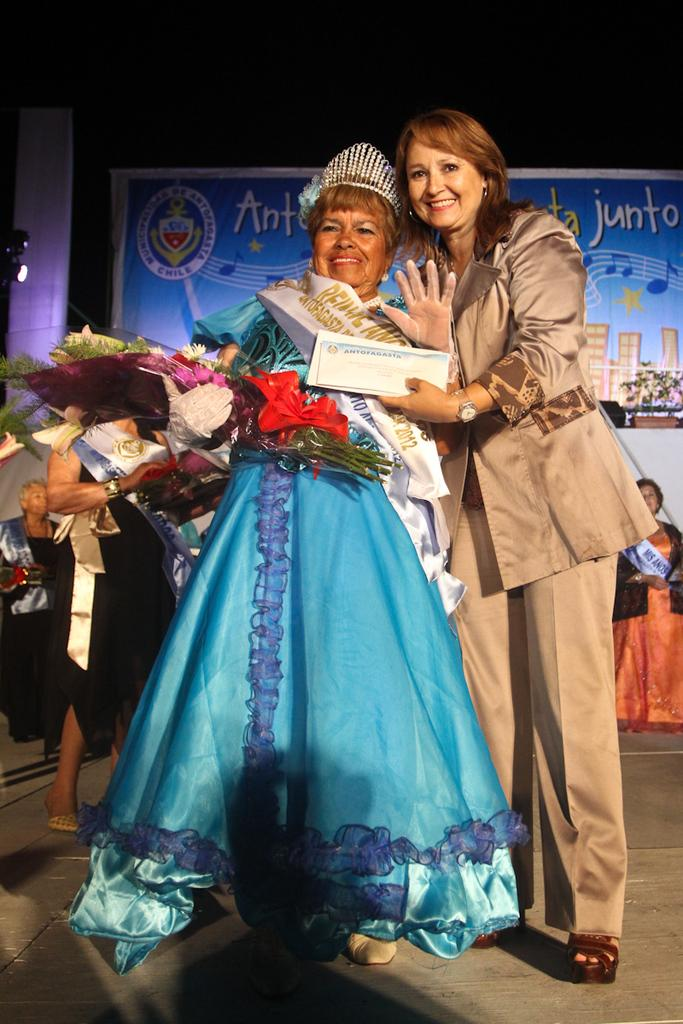How many people are in the image? There are people in the image, but the exact number is not specified. What is one person holding in the image? One person is holding a bouquet in the image. What else can be seen in the image besides the people? There is a banner visible in the image. What type of plastic material is used to make the peace sign in the image? There is no peace sign or plastic material mentioned in the image. 